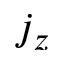Convert formula to latex. <formula><loc_0><loc_0><loc_500><loc_500>j _ { z }</formula> 